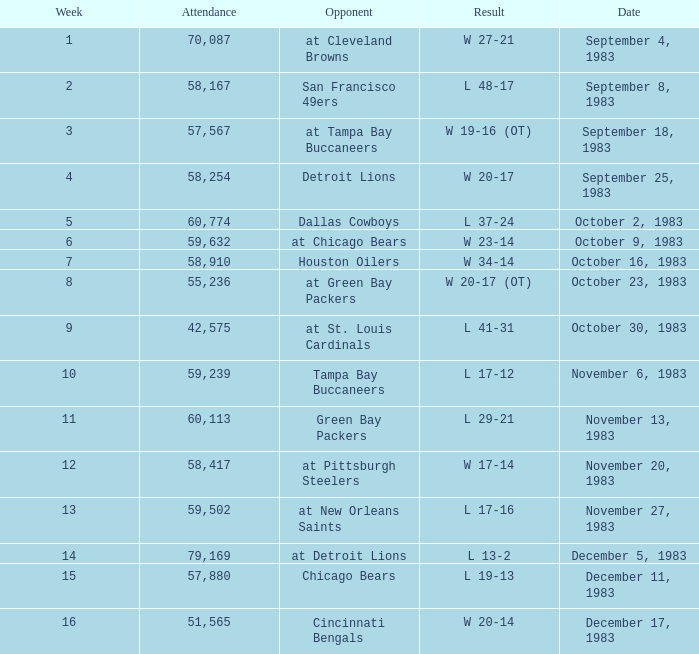What happened on November 20, 1983 before week 15? W 17-14. 